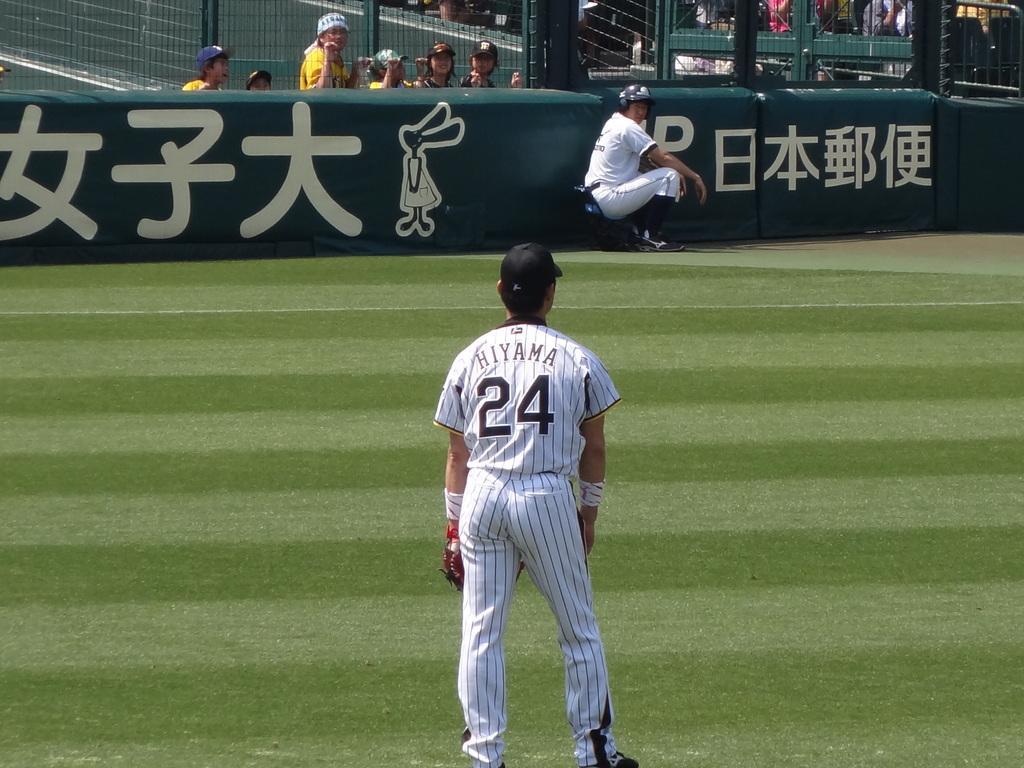Please provide a concise description of this image. In this picture I can see a person standing, there is a person sitting, there are birds, there are iron grilles, and in the background there are group of people. 